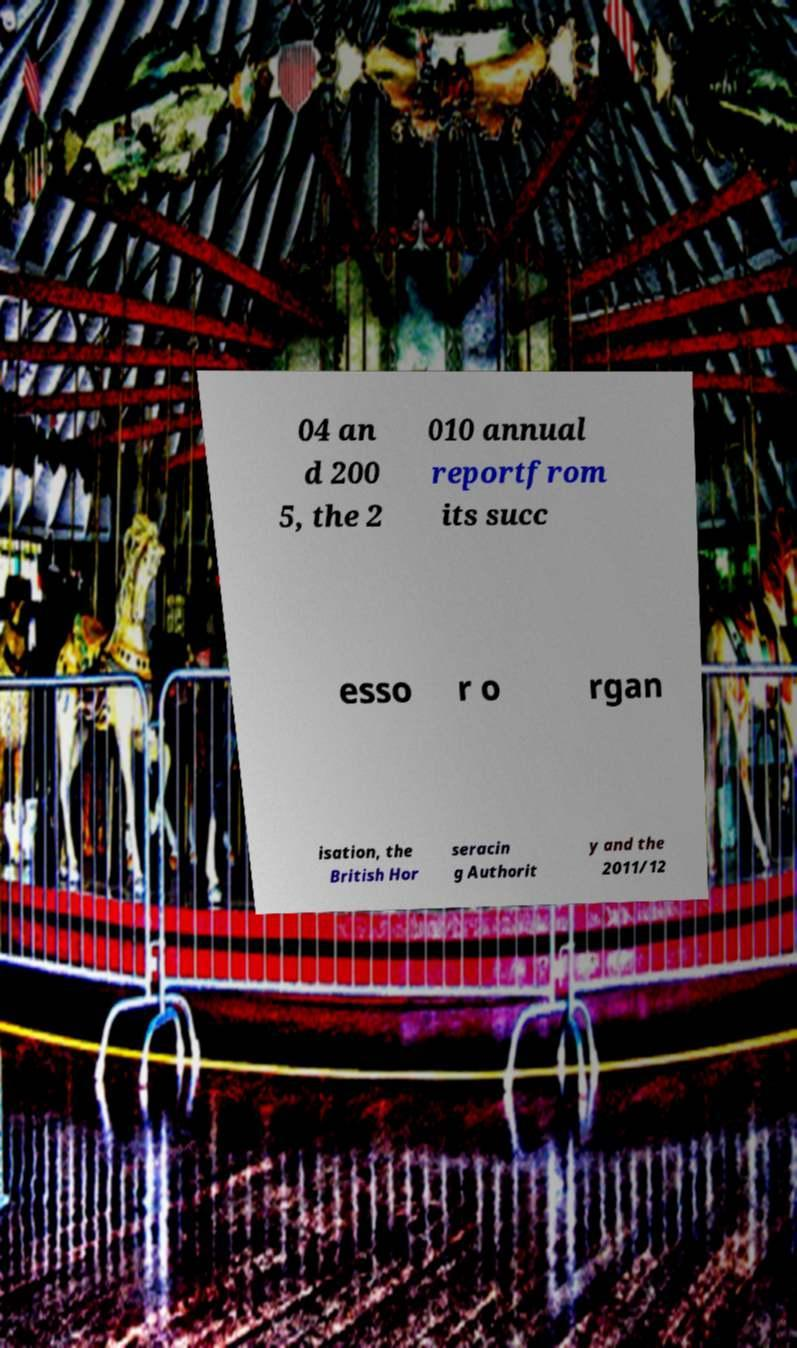Please read and relay the text visible in this image. What does it say? 04 an d 200 5, the 2 010 annual reportfrom its succ esso r o rgan isation, the British Hor seracin g Authorit y and the 2011/12 